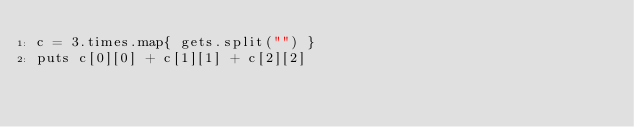<code> <loc_0><loc_0><loc_500><loc_500><_Ruby_>c = 3.times.map{ gets.split("") }
puts c[0][0] + c[1][1] + c[2][2]</code> 